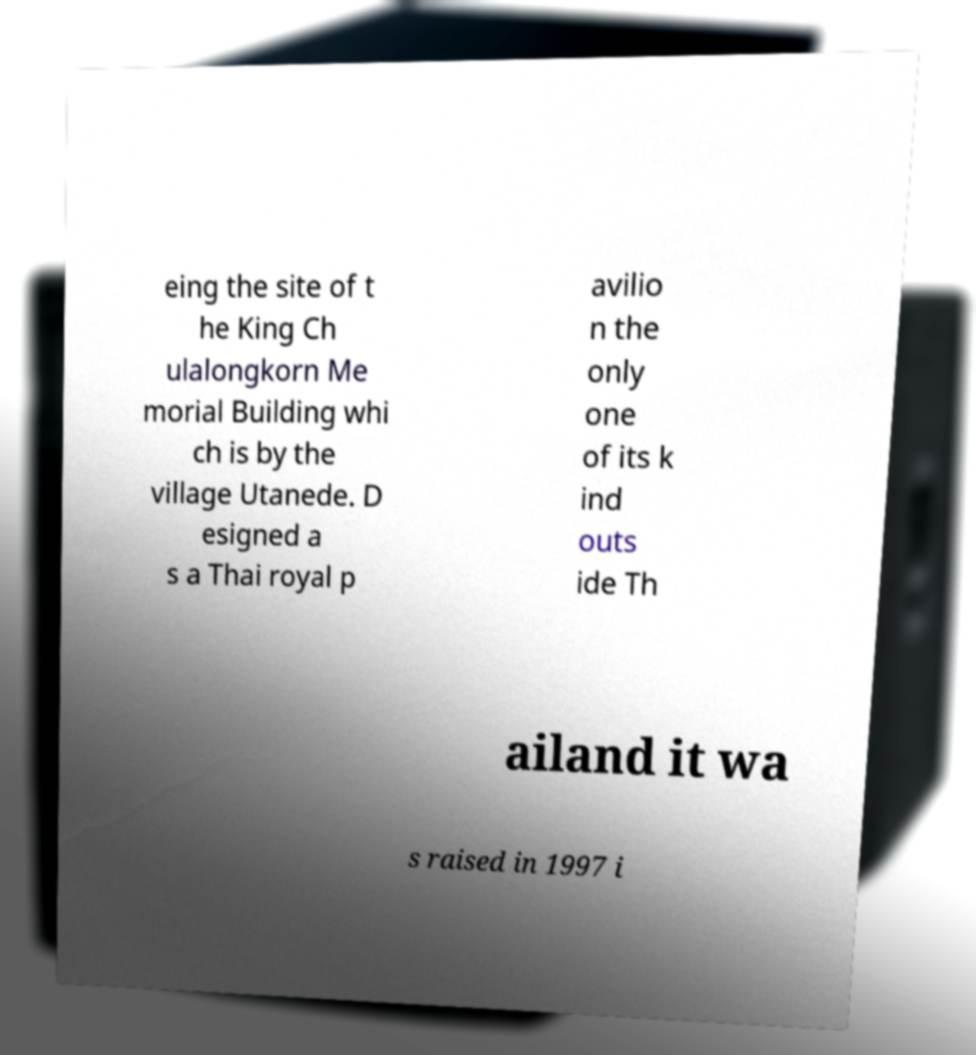Please identify and transcribe the text found in this image. eing the site of t he King Ch ulalongkorn Me morial Building whi ch is by the village Utanede. D esigned a s a Thai royal p avilio n the only one of its k ind outs ide Th ailand it wa s raised in 1997 i 